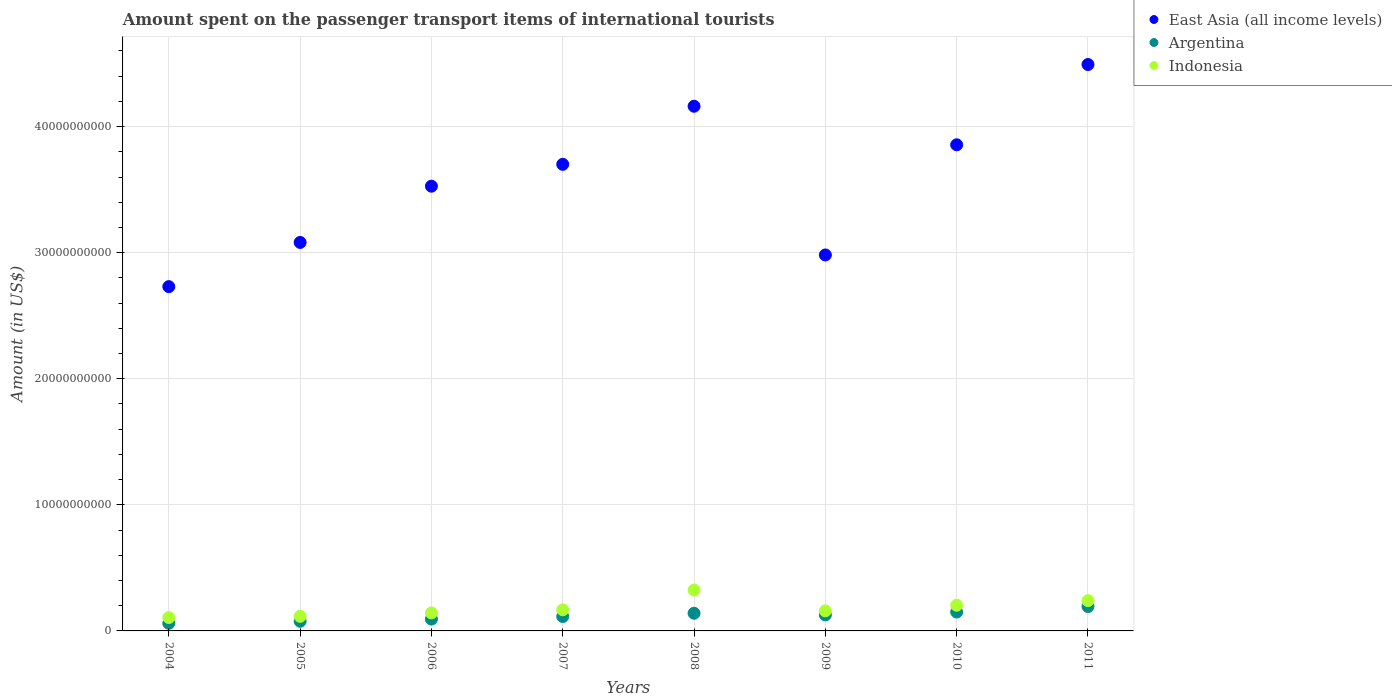How many different coloured dotlines are there?
Ensure brevity in your answer.  3. Is the number of dotlines equal to the number of legend labels?
Offer a terse response. Yes. What is the amount spent on the passenger transport items of international tourists in East Asia (all income levels) in 2004?
Ensure brevity in your answer.  2.73e+1. Across all years, what is the maximum amount spent on the passenger transport items of international tourists in Argentina?
Give a very brief answer. 1.94e+09. Across all years, what is the minimum amount spent on the passenger transport items of international tourists in Argentina?
Keep it short and to the point. 6.04e+08. In which year was the amount spent on the passenger transport items of international tourists in East Asia (all income levels) maximum?
Provide a succinct answer. 2011. In which year was the amount spent on the passenger transport items of international tourists in Argentina minimum?
Your answer should be compact. 2004. What is the total amount spent on the passenger transport items of international tourists in Argentina in the graph?
Offer a terse response. 9.55e+09. What is the difference between the amount spent on the passenger transport items of international tourists in Argentina in 2005 and that in 2011?
Offer a very short reply. -1.17e+09. What is the difference between the amount spent on the passenger transport items of international tourists in Indonesia in 2004 and the amount spent on the passenger transport items of international tourists in Argentina in 2009?
Offer a very short reply. -2.10e+08. What is the average amount spent on the passenger transport items of international tourists in Indonesia per year?
Keep it short and to the point. 1.82e+09. In the year 2006, what is the difference between the amount spent on the passenger transport items of international tourists in East Asia (all income levels) and amount spent on the passenger transport items of international tourists in Indonesia?
Ensure brevity in your answer.  3.38e+1. In how many years, is the amount spent on the passenger transport items of international tourists in East Asia (all income levels) greater than 26000000000 US$?
Offer a terse response. 8. What is the ratio of the amount spent on the passenger transport items of international tourists in Indonesia in 2004 to that in 2011?
Provide a short and direct response. 0.44. Is the difference between the amount spent on the passenger transport items of international tourists in East Asia (all income levels) in 2006 and 2007 greater than the difference between the amount spent on the passenger transport items of international tourists in Indonesia in 2006 and 2007?
Offer a terse response. No. What is the difference between the highest and the second highest amount spent on the passenger transport items of international tourists in Argentina?
Keep it short and to the point. 4.38e+08. What is the difference between the highest and the lowest amount spent on the passenger transport items of international tourists in Indonesia?
Offer a very short reply. 2.18e+09. Does the amount spent on the passenger transport items of international tourists in Indonesia monotonically increase over the years?
Give a very brief answer. No. Does the graph contain any zero values?
Provide a succinct answer. No. How are the legend labels stacked?
Your answer should be compact. Vertical. What is the title of the graph?
Your answer should be very brief. Amount spent on the passenger transport items of international tourists. Does "United Kingdom" appear as one of the legend labels in the graph?
Ensure brevity in your answer.  No. What is the label or title of the X-axis?
Provide a short and direct response. Years. What is the label or title of the Y-axis?
Provide a succinct answer. Amount (in US$). What is the Amount (in US$) in East Asia (all income levels) in 2004?
Your response must be concise. 2.73e+1. What is the Amount (in US$) in Argentina in 2004?
Give a very brief answer. 6.04e+08. What is the Amount (in US$) of Indonesia in 2004?
Your response must be concise. 1.06e+09. What is the Amount (in US$) of East Asia (all income levels) in 2005?
Your answer should be very brief. 3.08e+1. What is the Amount (in US$) of Argentina in 2005?
Offer a terse response. 7.64e+08. What is the Amount (in US$) of Indonesia in 2005?
Make the answer very short. 1.16e+09. What is the Amount (in US$) of East Asia (all income levels) in 2006?
Make the answer very short. 3.53e+1. What is the Amount (in US$) of Argentina in 2006?
Give a very brief answer. 9.39e+08. What is the Amount (in US$) of Indonesia in 2006?
Ensure brevity in your answer.  1.43e+09. What is the Amount (in US$) in East Asia (all income levels) in 2007?
Offer a very short reply. 3.70e+1. What is the Amount (in US$) in Argentina in 2007?
Provide a succinct answer. 1.14e+09. What is the Amount (in US$) of Indonesia in 2007?
Provide a succinct answer. 1.67e+09. What is the Amount (in US$) in East Asia (all income levels) in 2008?
Offer a terse response. 4.16e+1. What is the Amount (in US$) of Argentina in 2008?
Give a very brief answer. 1.40e+09. What is the Amount (in US$) of Indonesia in 2008?
Provide a succinct answer. 3.25e+09. What is the Amount (in US$) in East Asia (all income levels) in 2009?
Offer a terse response. 2.98e+1. What is the Amount (in US$) of Argentina in 2009?
Keep it short and to the point. 1.27e+09. What is the Amount (in US$) in Indonesia in 2009?
Provide a succinct answer. 1.59e+09. What is the Amount (in US$) in East Asia (all income levels) in 2010?
Offer a very short reply. 3.86e+1. What is the Amount (in US$) in Argentina in 2010?
Provide a short and direct response. 1.50e+09. What is the Amount (in US$) of Indonesia in 2010?
Your answer should be compact. 2.04e+09. What is the Amount (in US$) of East Asia (all income levels) in 2011?
Your answer should be very brief. 4.49e+1. What is the Amount (in US$) in Argentina in 2011?
Your response must be concise. 1.94e+09. What is the Amount (in US$) in Indonesia in 2011?
Your response must be concise. 2.40e+09. Across all years, what is the maximum Amount (in US$) in East Asia (all income levels)?
Your response must be concise. 4.49e+1. Across all years, what is the maximum Amount (in US$) in Argentina?
Ensure brevity in your answer.  1.94e+09. Across all years, what is the maximum Amount (in US$) of Indonesia?
Offer a terse response. 3.25e+09. Across all years, what is the minimum Amount (in US$) in East Asia (all income levels)?
Your answer should be compact. 2.73e+1. Across all years, what is the minimum Amount (in US$) in Argentina?
Provide a succinct answer. 6.04e+08. Across all years, what is the minimum Amount (in US$) in Indonesia?
Your answer should be compact. 1.06e+09. What is the total Amount (in US$) in East Asia (all income levels) in the graph?
Ensure brevity in your answer.  2.85e+11. What is the total Amount (in US$) of Argentina in the graph?
Keep it short and to the point. 9.55e+09. What is the total Amount (in US$) of Indonesia in the graph?
Your response must be concise. 1.46e+1. What is the difference between the Amount (in US$) of East Asia (all income levels) in 2004 and that in 2005?
Your answer should be compact. -3.51e+09. What is the difference between the Amount (in US$) of Argentina in 2004 and that in 2005?
Your response must be concise. -1.60e+08. What is the difference between the Amount (in US$) in Indonesia in 2004 and that in 2005?
Provide a succinct answer. -9.40e+07. What is the difference between the Amount (in US$) of East Asia (all income levels) in 2004 and that in 2006?
Your answer should be compact. -7.97e+09. What is the difference between the Amount (in US$) of Argentina in 2004 and that in 2006?
Make the answer very short. -3.35e+08. What is the difference between the Amount (in US$) in Indonesia in 2004 and that in 2006?
Your answer should be compact. -3.66e+08. What is the difference between the Amount (in US$) of East Asia (all income levels) in 2004 and that in 2007?
Ensure brevity in your answer.  -9.70e+09. What is the difference between the Amount (in US$) of Argentina in 2004 and that in 2007?
Your response must be concise. -5.38e+08. What is the difference between the Amount (in US$) of Indonesia in 2004 and that in 2007?
Ensure brevity in your answer.  -6.12e+08. What is the difference between the Amount (in US$) of East Asia (all income levels) in 2004 and that in 2008?
Provide a succinct answer. -1.43e+1. What is the difference between the Amount (in US$) in Argentina in 2004 and that in 2008?
Offer a very short reply. -7.97e+08. What is the difference between the Amount (in US$) in Indonesia in 2004 and that in 2008?
Make the answer very short. -2.18e+09. What is the difference between the Amount (in US$) of East Asia (all income levels) in 2004 and that in 2009?
Offer a terse response. -2.51e+09. What is the difference between the Amount (in US$) of Argentina in 2004 and that in 2009?
Your answer should be very brief. -6.68e+08. What is the difference between the Amount (in US$) in Indonesia in 2004 and that in 2009?
Offer a terse response. -5.30e+08. What is the difference between the Amount (in US$) in East Asia (all income levels) in 2004 and that in 2010?
Provide a succinct answer. -1.12e+1. What is the difference between the Amount (in US$) in Argentina in 2004 and that in 2010?
Provide a short and direct response. -8.93e+08. What is the difference between the Amount (in US$) in Indonesia in 2004 and that in 2010?
Your answer should be very brief. -9.75e+08. What is the difference between the Amount (in US$) in East Asia (all income levels) in 2004 and that in 2011?
Offer a terse response. -1.76e+1. What is the difference between the Amount (in US$) in Argentina in 2004 and that in 2011?
Ensure brevity in your answer.  -1.33e+09. What is the difference between the Amount (in US$) of Indonesia in 2004 and that in 2011?
Your answer should be very brief. -1.34e+09. What is the difference between the Amount (in US$) in East Asia (all income levels) in 2005 and that in 2006?
Keep it short and to the point. -4.46e+09. What is the difference between the Amount (in US$) of Argentina in 2005 and that in 2006?
Ensure brevity in your answer.  -1.75e+08. What is the difference between the Amount (in US$) in Indonesia in 2005 and that in 2006?
Keep it short and to the point. -2.72e+08. What is the difference between the Amount (in US$) of East Asia (all income levels) in 2005 and that in 2007?
Your answer should be very brief. -6.20e+09. What is the difference between the Amount (in US$) in Argentina in 2005 and that in 2007?
Offer a terse response. -3.78e+08. What is the difference between the Amount (in US$) of Indonesia in 2005 and that in 2007?
Give a very brief answer. -5.18e+08. What is the difference between the Amount (in US$) in East Asia (all income levels) in 2005 and that in 2008?
Provide a succinct answer. -1.08e+1. What is the difference between the Amount (in US$) of Argentina in 2005 and that in 2008?
Ensure brevity in your answer.  -6.37e+08. What is the difference between the Amount (in US$) in Indonesia in 2005 and that in 2008?
Your answer should be compact. -2.09e+09. What is the difference between the Amount (in US$) in East Asia (all income levels) in 2005 and that in 2009?
Your answer should be very brief. 9.93e+08. What is the difference between the Amount (in US$) of Argentina in 2005 and that in 2009?
Your response must be concise. -5.08e+08. What is the difference between the Amount (in US$) in Indonesia in 2005 and that in 2009?
Provide a short and direct response. -4.36e+08. What is the difference between the Amount (in US$) in East Asia (all income levels) in 2005 and that in 2010?
Your answer should be compact. -7.74e+09. What is the difference between the Amount (in US$) of Argentina in 2005 and that in 2010?
Ensure brevity in your answer.  -7.33e+08. What is the difference between the Amount (in US$) in Indonesia in 2005 and that in 2010?
Provide a short and direct response. -8.81e+08. What is the difference between the Amount (in US$) in East Asia (all income levels) in 2005 and that in 2011?
Provide a succinct answer. -1.41e+1. What is the difference between the Amount (in US$) in Argentina in 2005 and that in 2011?
Offer a terse response. -1.17e+09. What is the difference between the Amount (in US$) in Indonesia in 2005 and that in 2011?
Your answer should be very brief. -1.24e+09. What is the difference between the Amount (in US$) in East Asia (all income levels) in 2006 and that in 2007?
Give a very brief answer. -1.73e+09. What is the difference between the Amount (in US$) of Argentina in 2006 and that in 2007?
Offer a terse response. -2.03e+08. What is the difference between the Amount (in US$) of Indonesia in 2006 and that in 2007?
Offer a terse response. -2.46e+08. What is the difference between the Amount (in US$) in East Asia (all income levels) in 2006 and that in 2008?
Give a very brief answer. -6.34e+09. What is the difference between the Amount (in US$) of Argentina in 2006 and that in 2008?
Ensure brevity in your answer.  -4.62e+08. What is the difference between the Amount (in US$) in Indonesia in 2006 and that in 2008?
Provide a succinct answer. -1.82e+09. What is the difference between the Amount (in US$) of East Asia (all income levels) in 2006 and that in 2009?
Your answer should be compact. 5.45e+09. What is the difference between the Amount (in US$) in Argentina in 2006 and that in 2009?
Make the answer very short. -3.33e+08. What is the difference between the Amount (in US$) of Indonesia in 2006 and that in 2009?
Your answer should be very brief. -1.64e+08. What is the difference between the Amount (in US$) in East Asia (all income levels) in 2006 and that in 2010?
Your response must be concise. -3.28e+09. What is the difference between the Amount (in US$) in Argentina in 2006 and that in 2010?
Ensure brevity in your answer.  -5.58e+08. What is the difference between the Amount (in US$) of Indonesia in 2006 and that in 2010?
Your answer should be very brief. -6.09e+08. What is the difference between the Amount (in US$) of East Asia (all income levels) in 2006 and that in 2011?
Provide a succinct answer. -9.65e+09. What is the difference between the Amount (in US$) of Argentina in 2006 and that in 2011?
Give a very brief answer. -9.96e+08. What is the difference between the Amount (in US$) of Indonesia in 2006 and that in 2011?
Offer a very short reply. -9.70e+08. What is the difference between the Amount (in US$) of East Asia (all income levels) in 2007 and that in 2008?
Make the answer very short. -4.61e+09. What is the difference between the Amount (in US$) in Argentina in 2007 and that in 2008?
Your answer should be very brief. -2.59e+08. What is the difference between the Amount (in US$) in Indonesia in 2007 and that in 2008?
Your answer should be very brief. -1.57e+09. What is the difference between the Amount (in US$) in East Asia (all income levels) in 2007 and that in 2009?
Provide a succinct answer. 7.19e+09. What is the difference between the Amount (in US$) in Argentina in 2007 and that in 2009?
Provide a succinct answer. -1.30e+08. What is the difference between the Amount (in US$) of Indonesia in 2007 and that in 2009?
Make the answer very short. 8.20e+07. What is the difference between the Amount (in US$) in East Asia (all income levels) in 2007 and that in 2010?
Offer a very short reply. -1.55e+09. What is the difference between the Amount (in US$) of Argentina in 2007 and that in 2010?
Make the answer very short. -3.55e+08. What is the difference between the Amount (in US$) of Indonesia in 2007 and that in 2010?
Provide a succinct answer. -3.63e+08. What is the difference between the Amount (in US$) in East Asia (all income levels) in 2007 and that in 2011?
Offer a very short reply. -7.92e+09. What is the difference between the Amount (in US$) in Argentina in 2007 and that in 2011?
Provide a short and direct response. -7.93e+08. What is the difference between the Amount (in US$) in Indonesia in 2007 and that in 2011?
Keep it short and to the point. -7.24e+08. What is the difference between the Amount (in US$) of East Asia (all income levels) in 2008 and that in 2009?
Offer a very short reply. 1.18e+1. What is the difference between the Amount (in US$) in Argentina in 2008 and that in 2009?
Give a very brief answer. 1.29e+08. What is the difference between the Amount (in US$) in Indonesia in 2008 and that in 2009?
Your response must be concise. 1.66e+09. What is the difference between the Amount (in US$) in East Asia (all income levels) in 2008 and that in 2010?
Offer a terse response. 3.06e+09. What is the difference between the Amount (in US$) in Argentina in 2008 and that in 2010?
Offer a terse response. -9.60e+07. What is the difference between the Amount (in US$) in Indonesia in 2008 and that in 2010?
Your response must be concise. 1.21e+09. What is the difference between the Amount (in US$) of East Asia (all income levels) in 2008 and that in 2011?
Provide a succinct answer. -3.31e+09. What is the difference between the Amount (in US$) in Argentina in 2008 and that in 2011?
Ensure brevity in your answer.  -5.34e+08. What is the difference between the Amount (in US$) of Indonesia in 2008 and that in 2011?
Provide a succinct answer. 8.49e+08. What is the difference between the Amount (in US$) in East Asia (all income levels) in 2009 and that in 2010?
Provide a short and direct response. -8.74e+09. What is the difference between the Amount (in US$) of Argentina in 2009 and that in 2010?
Provide a succinct answer. -2.25e+08. What is the difference between the Amount (in US$) in Indonesia in 2009 and that in 2010?
Provide a short and direct response. -4.45e+08. What is the difference between the Amount (in US$) of East Asia (all income levels) in 2009 and that in 2011?
Give a very brief answer. -1.51e+1. What is the difference between the Amount (in US$) in Argentina in 2009 and that in 2011?
Make the answer very short. -6.63e+08. What is the difference between the Amount (in US$) in Indonesia in 2009 and that in 2011?
Make the answer very short. -8.06e+08. What is the difference between the Amount (in US$) in East Asia (all income levels) in 2010 and that in 2011?
Give a very brief answer. -6.37e+09. What is the difference between the Amount (in US$) in Argentina in 2010 and that in 2011?
Offer a terse response. -4.38e+08. What is the difference between the Amount (in US$) of Indonesia in 2010 and that in 2011?
Provide a succinct answer. -3.61e+08. What is the difference between the Amount (in US$) of East Asia (all income levels) in 2004 and the Amount (in US$) of Argentina in 2005?
Keep it short and to the point. 2.65e+1. What is the difference between the Amount (in US$) of East Asia (all income levels) in 2004 and the Amount (in US$) of Indonesia in 2005?
Offer a terse response. 2.61e+1. What is the difference between the Amount (in US$) of Argentina in 2004 and the Amount (in US$) of Indonesia in 2005?
Keep it short and to the point. -5.52e+08. What is the difference between the Amount (in US$) in East Asia (all income levels) in 2004 and the Amount (in US$) in Argentina in 2006?
Keep it short and to the point. 2.64e+1. What is the difference between the Amount (in US$) in East Asia (all income levels) in 2004 and the Amount (in US$) in Indonesia in 2006?
Give a very brief answer. 2.59e+1. What is the difference between the Amount (in US$) of Argentina in 2004 and the Amount (in US$) of Indonesia in 2006?
Provide a succinct answer. -8.24e+08. What is the difference between the Amount (in US$) in East Asia (all income levels) in 2004 and the Amount (in US$) in Argentina in 2007?
Your response must be concise. 2.62e+1. What is the difference between the Amount (in US$) of East Asia (all income levels) in 2004 and the Amount (in US$) of Indonesia in 2007?
Offer a very short reply. 2.56e+1. What is the difference between the Amount (in US$) of Argentina in 2004 and the Amount (in US$) of Indonesia in 2007?
Provide a succinct answer. -1.07e+09. What is the difference between the Amount (in US$) in East Asia (all income levels) in 2004 and the Amount (in US$) in Argentina in 2008?
Offer a very short reply. 2.59e+1. What is the difference between the Amount (in US$) of East Asia (all income levels) in 2004 and the Amount (in US$) of Indonesia in 2008?
Ensure brevity in your answer.  2.41e+1. What is the difference between the Amount (in US$) in Argentina in 2004 and the Amount (in US$) in Indonesia in 2008?
Provide a short and direct response. -2.64e+09. What is the difference between the Amount (in US$) in East Asia (all income levels) in 2004 and the Amount (in US$) in Argentina in 2009?
Give a very brief answer. 2.60e+1. What is the difference between the Amount (in US$) in East Asia (all income levels) in 2004 and the Amount (in US$) in Indonesia in 2009?
Make the answer very short. 2.57e+1. What is the difference between the Amount (in US$) of Argentina in 2004 and the Amount (in US$) of Indonesia in 2009?
Your answer should be compact. -9.88e+08. What is the difference between the Amount (in US$) of East Asia (all income levels) in 2004 and the Amount (in US$) of Argentina in 2010?
Give a very brief answer. 2.58e+1. What is the difference between the Amount (in US$) in East Asia (all income levels) in 2004 and the Amount (in US$) in Indonesia in 2010?
Give a very brief answer. 2.53e+1. What is the difference between the Amount (in US$) of Argentina in 2004 and the Amount (in US$) of Indonesia in 2010?
Offer a very short reply. -1.43e+09. What is the difference between the Amount (in US$) in East Asia (all income levels) in 2004 and the Amount (in US$) in Argentina in 2011?
Your answer should be compact. 2.54e+1. What is the difference between the Amount (in US$) of East Asia (all income levels) in 2004 and the Amount (in US$) of Indonesia in 2011?
Offer a very short reply. 2.49e+1. What is the difference between the Amount (in US$) in Argentina in 2004 and the Amount (in US$) in Indonesia in 2011?
Provide a short and direct response. -1.79e+09. What is the difference between the Amount (in US$) of East Asia (all income levels) in 2005 and the Amount (in US$) of Argentina in 2006?
Your answer should be very brief. 2.99e+1. What is the difference between the Amount (in US$) of East Asia (all income levels) in 2005 and the Amount (in US$) of Indonesia in 2006?
Ensure brevity in your answer.  2.94e+1. What is the difference between the Amount (in US$) in Argentina in 2005 and the Amount (in US$) in Indonesia in 2006?
Offer a very short reply. -6.64e+08. What is the difference between the Amount (in US$) in East Asia (all income levels) in 2005 and the Amount (in US$) in Argentina in 2007?
Provide a short and direct response. 2.97e+1. What is the difference between the Amount (in US$) of East Asia (all income levels) in 2005 and the Amount (in US$) of Indonesia in 2007?
Provide a short and direct response. 2.91e+1. What is the difference between the Amount (in US$) of Argentina in 2005 and the Amount (in US$) of Indonesia in 2007?
Provide a succinct answer. -9.10e+08. What is the difference between the Amount (in US$) in East Asia (all income levels) in 2005 and the Amount (in US$) in Argentina in 2008?
Offer a very short reply. 2.94e+1. What is the difference between the Amount (in US$) in East Asia (all income levels) in 2005 and the Amount (in US$) in Indonesia in 2008?
Provide a succinct answer. 2.76e+1. What is the difference between the Amount (in US$) of Argentina in 2005 and the Amount (in US$) of Indonesia in 2008?
Your response must be concise. -2.48e+09. What is the difference between the Amount (in US$) of East Asia (all income levels) in 2005 and the Amount (in US$) of Argentina in 2009?
Offer a terse response. 2.95e+1. What is the difference between the Amount (in US$) of East Asia (all income levels) in 2005 and the Amount (in US$) of Indonesia in 2009?
Your answer should be very brief. 2.92e+1. What is the difference between the Amount (in US$) of Argentina in 2005 and the Amount (in US$) of Indonesia in 2009?
Your answer should be very brief. -8.28e+08. What is the difference between the Amount (in US$) of East Asia (all income levels) in 2005 and the Amount (in US$) of Argentina in 2010?
Ensure brevity in your answer.  2.93e+1. What is the difference between the Amount (in US$) of East Asia (all income levels) in 2005 and the Amount (in US$) of Indonesia in 2010?
Provide a short and direct response. 2.88e+1. What is the difference between the Amount (in US$) of Argentina in 2005 and the Amount (in US$) of Indonesia in 2010?
Provide a short and direct response. -1.27e+09. What is the difference between the Amount (in US$) of East Asia (all income levels) in 2005 and the Amount (in US$) of Argentina in 2011?
Provide a succinct answer. 2.89e+1. What is the difference between the Amount (in US$) of East Asia (all income levels) in 2005 and the Amount (in US$) of Indonesia in 2011?
Your answer should be compact. 2.84e+1. What is the difference between the Amount (in US$) of Argentina in 2005 and the Amount (in US$) of Indonesia in 2011?
Keep it short and to the point. -1.63e+09. What is the difference between the Amount (in US$) in East Asia (all income levels) in 2006 and the Amount (in US$) in Argentina in 2007?
Offer a very short reply. 3.41e+1. What is the difference between the Amount (in US$) of East Asia (all income levels) in 2006 and the Amount (in US$) of Indonesia in 2007?
Keep it short and to the point. 3.36e+1. What is the difference between the Amount (in US$) of Argentina in 2006 and the Amount (in US$) of Indonesia in 2007?
Your answer should be very brief. -7.35e+08. What is the difference between the Amount (in US$) of East Asia (all income levels) in 2006 and the Amount (in US$) of Argentina in 2008?
Provide a short and direct response. 3.39e+1. What is the difference between the Amount (in US$) of East Asia (all income levels) in 2006 and the Amount (in US$) of Indonesia in 2008?
Keep it short and to the point. 3.20e+1. What is the difference between the Amount (in US$) of Argentina in 2006 and the Amount (in US$) of Indonesia in 2008?
Ensure brevity in your answer.  -2.31e+09. What is the difference between the Amount (in US$) of East Asia (all income levels) in 2006 and the Amount (in US$) of Argentina in 2009?
Ensure brevity in your answer.  3.40e+1. What is the difference between the Amount (in US$) in East Asia (all income levels) in 2006 and the Amount (in US$) in Indonesia in 2009?
Make the answer very short. 3.37e+1. What is the difference between the Amount (in US$) of Argentina in 2006 and the Amount (in US$) of Indonesia in 2009?
Make the answer very short. -6.53e+08. What is the difference between the Amount (in US$) of East Asia (all income levels) in 2006 and the Amount (in US$) of Argentina in 2010?
Your answer should be very brief. 3.38e+1. What is the difference between the Amount (in US$) of East Asia (all income levels) in 2006 and the Amount (in US$) of Indonesia in 2010?
Give a very brief answer. 3.32e+1. What is the difference between the Amount (in US$) in Argentina in 2006 and the Amount (in US$) in Indonesia in 2010?
Give a very brief answer. -1.10e+09. What is the difference between the Amount (in US$) of East Asia (all income levels) in 2006 and the Amount (in US$) of Argentina in 2011?
Your response must be concise. 3.33e+1. What is the difference between the Amount (in US$) of East Asia (all income levels) in 2006 and the Amount (in US$) of Indonesia in 2011?
Offer a very short reply. 3.29e+1. What is the difference between the Amount (in US$) of Argentina in 2006 and the Amount (in US$) of Indonesia in 2011?
Offer a very short reply. -1.46e+09. What is the difference between the Amount (in US$) of East Asia (all income levels) in 2007 and the Amount (in US$) of Argentina in 2008?
Provide a short and direct response. 3.56e+1. What is the difference between the Amount (in US$) in East Asia (all income levels) in 2007 and the Amount (in US$) in Indonesia in 2008?
Make the answer very short. 3.38e+1. What is the difference between the Amount (in US$) in Argentina in 2007 and the Amount (in US$) in Indonesia in 2008?
Provide a succinct answer. -2.10e+09. What is the difference between the Amount (in US$) of East Asia (all income levels) in 2007 and the Amount (in US$) of Argentina in 2009?
Give a very brief answer. 3.57e+1. What is the difference between the Amount (in US$) in East Asia (all income levels) in 2007 and the Amount (in US$) in Indonesia in 2009?
Your answer should be very brief. 3.54e+1. What is the difference between the Amount (in US$) of Argentina in 2007 and the Amount (in US$) of Indonesia in 2009?
Make the answer very short. -4.50e+08. What is the difference between the Amount (in US$) in East Asia (all income levels) in 2007 and the Amount (in US$) in Argentina in 2010?
Your answer should be very brief. 3.55e+1. What is the difference between the Amount (in US$) in East Asia (all income levels) in 2007 and the Amount (in US$) in Indonesia in 2010?
Provide a succinct answer. 3.50e+1. What is the difference between the Amount (in US$) in Argentina in 2007 and the Amount (in US$) in Indonesia in 2010?
Keep it short and to the point. -8.95e+08. What is the difference between the Amount (in US$) of East Asia (all income levels) in 2007 and the Amount (in US$) of Argentina in 2011?
Ensure brevity in your answer.  3.51e+1. What is the difference between the Amount (in US$) of East Asia (all income levels) in 2007 and the Amount (in US$) of Indonesia in 2011?
Give a very brief answer. 3.46e+1. What is the difference between the Amount (in US$) of Argentina in 2007 and the Amount (in US$) of Indonesia in 2011?
Provide a succinct answer. -1.26e+09. What is the difference between the Amount (in US$) in East Asia (all income levels) in 2008 and the Amount (in US$) in Argentina in 2009?
Offer a very short reply. 4.03e+1. What is the difference between the Amount (in US$) in East Asia (all income levels) in 2008 and the Amount (in US$) in Indonesia in 2009?
Offer a very short reply. 4.00e+1. What is the difference between the Amount (in US$) of Argentina in 2008 and the Amount (in US$) of Indonesia in 2009?
Your answer should be very brief. -1.91e+08. What is the difference between the Amount (in US$) in East Asia (all income levels) in 2008 and the Amount (in US$) in Argentina in 2010?
Your answer should be compact. 4.01e+1. What is the difference between the Amount (in US$) of East Asia (all income levels) in 2008 and the Amount (in US$) of Indonesia in 2010?
Your response must be concise. 3.96e+1. What is the difference between the Amount (in US$) of Argentina in 2008 and the Amount (in US$) of Indonesia in 2010?
Offer a very short reply. -6.36e+08. What is the difference between the Amount (in US$) of East Asia (all income levels) in 2008 and the Amount (in US$) of Argentina in 2011?
Offer a very short reply. 3.97e+1. What is the difference between the Amount (in US$) of East Asia (all income levels) in 2008 and the Amount (in US$) of Indonesia in 2011?
Keep it short and to the point. 3.92e+1. What is the difference between the Amount (in US$) in Argentina in 2008 and the Amount (in US$) in Indonesia in 2011?
Your response must be concise. -9.97e+08. What is the difference between the Amount (in US$) of East Asia (all income levels) in 2009 and the Amount (in US$) of Argentina in 2010?
Your response must be concise. 2.83e+1. What is the difference between the Amount (in US$) in East Asia (all income levels) in 2009 and the Amount (in US$) in Indonesia in 2010?
Offer a terse response. 2.78e+1. What is the difference between the Amount (in US$) in Argentina in 2009 and the Amount (in US$) in Indonesia in 2010?
Make the answer very short. -7.65e+08. What is the difference between the Amount (in US$) of East Asia (all income levels) in 2009 and the Amount (in US$) of Argentina in 2011?
Give a very brief answer. 2.79e+1. What is the difference between the Amount (in US$) in East Asia (all income levels) in 2009 and the Amount (in US$) in Indonesia in 2011?
Offer a very short reply. 2.74e+1. What is the difference between the Amount (in US$) of Argentina in 2009 and the Amount (in US$) of Indonesia in 2011?
Keep it short and to the point. -1.13e+09. What is the difference between the Amount (in US$) of East Asia (all income levels) in 2010 and the Amount (in US$) of Argentina in 2011?
Provide a short and direct response. 3.66e+1. What is the difference between the Amount (in US$) in East Asia (all income levels) in 2010 and the Amount (in US$) in Indonesia in 2011?
Provide a short and direct response. 3.62e+1. What is the difference between the Amount (in US$) of Argentina in 2010 and the Amount (in US$) of Indonesia in 2011?
Provide a short and direct response. -9.01e+08. What is the average Amount (in US$) in East Asia (all income levels) per year?
Provide a short and direct response. 3.57e+1. What is the average Amount (in US$) in Argentina per year?
Keep it short and to the point. 1.19e+09. What is the average Amount (in US$) of Indonesia per year?
Provide a short and direct response. 1.82e+09. In the year 2004, what is the difference between the Amount (in US$) of East Asia (all income levels) and Amount (in US$) of Argentina?
Ensure brevity in your answer.  2.67e+1. In the year 2004, what is the difference between the Amount (in US$) in East Asia (all income levels) and Amount (in US$) in Indonesia?
Make the answer very short. 2.62e+1. In the year 2004, what is the difference between the Amount (in US$) in Argentina and Amount (in US$) in Indonesia?
Provide a succinct answer. -4.58e+08. In the year 2005, what is the difference between the Amount (in US$) in East Asia (all income levels) and Amount (in US$) in Argentina?
Keep it short and to the point. 3.00e+1. In the year 2005, what is the difference between the Amount (in US$) in East Asia (all income levels) and Amount (in US$) in Indonesia?
Provide a short and direct response. 2.97e+1. In the year 2005, what is the difference between the Amount (in US$) in Argentina and Amount (in US$) in Indonesia?
Your answer should be compact. -3.92e+08. In the year 2006, what is the difference between the Amount (in US$) of East Asia (all income levels) and Amount (in US$) of Argentina?
Your answer should be very brief. 3.43e+1. In the year 2006, what is the difference between the Amount (in US$) of East Asia (all income levels) and Amount (in US$) of Indonesia?
Provide a succinct answer. 3.38e+1. In the year 2006, what is the difference between the Amount (in US$) of Argentina and Amount (in US$) of Indonesia?
Provide a succinct answer. -4.89e+08. In the year 2007, what is the difference between the Amount (in US$) in East Asia (all income levels) and Amount (in US$) in Argentina?
Your answer should be compact. 3.59e+1. In the year 2007, what is the difference between the Amount (in US$) of East Asia (all income levels) and Amount (in US$) of Indonesia?
Make the answer very short. 3.53e+1. In the year 2007, what is the difference between the Amount (in US$) in Argentina and Amount (in US$) in Indonesia?
Give a very brief answer. -5.32e+08. In the year 2008, what is the difference between the Amount (in US$) of East Asia (all income levels) and Amount (in US$) of Argentina?
Make the answer very short. 4.02e+1. In the year 2008, what is the difference between the Amount (in US$) of East Asia (all income levels) and Amount (in US$) of Indonesia?
Make the answer very short. 3.84e+1. In the year 2008, what is the difference between the Amount (in US$) in Argentina and Amount (in US$) in Indonesia?
Your answer should be very brief. -1.85e+09. In the year 2009, what is the difference between the Amount (in US$) in East Asia (all income levels) and Amount (in US$) in Argentina?
Offer a terse response. 2.85e+1. In the year 2009, what is the difference between the Amount (in US$) in East Asia (all income levels) and Amount (in US$) in Indonesia?
Provide a short and direct response. 2.82e+1. In the year 2009, what is the difference between the Amount (in US$) of Argentina and Amount (in US$) of Indonesia?
Provide a succinct answer. -3.20e+08. In the year 2010, what is the difference between the Amount (in US$) in East Asia (all income levels) and Amount (in US$) in Argentina?
Provide a succinct answer. 3.71e+1. In the year 2010, what is the difference between the Amount (in US$) of East Asia (all income levels) and Amount (in US$) of Indonesia?
Your answer should be very brief. 3.65e+1. In the year 2010, what is the difference between the Amount (in US$) of Argentina and Amount (in US$) of Indonesia?
Your answer should be compact. -5.40e+08. In the year 2011, what is the difference between the Amount (in US$) of East Asia (all income levels) and Amount (in US$) of Argentina?
Your answer should be very brief. 4.30e+1. In the year 2011, what is the difference between the Amount (in US$) in East Asia (all income levels) and Amount (in US$) in Indonesia?
Keep it short and to the point. 4.25e+1. In the year 2011, what is the difference between the Amount (in US$) of Argentina and Amount (in US$) of Indonesia?
Provide a short and direct response. -4.63e+08. What is the ratio of the Amount (in US$) of East Asia (all income levels) in 2004 to that in 2005?
Offer a very short reply. 0.89. What is the ratio of the Amount (in US$) in Argentina in 2004 to that in 2005?
Offer a very short reply. 0.79. What is the ratio of the Amount (in US$) of Indonesia in 2004 to that in 2005?
Keep it short and to the point. 0.92. What is the ratio of the Amount (in US$) of East Asia (all income levels) in 2004 to that in 2006?
Provide a succinct answer. 0.77. What is the ratio of the Amount (in US$) of Argentina in 2004 to that in 2006?
Your answer should be compact. 0.64. What is the ratio of the Amount (in US$) in Indonesia in 2004 to that in 2006?
Provide a succinct answer. 0.74. What is the ratio of the Amount (in US$) of East Asia (all income levels) in 2004 to that in 2007?
Provide a short and direct response. 0.74. What is the ratio of the Amount (in US$) in Argentina in 2004 to that in 2007?
Offer a very short reply. 0.53. What is the ratio of the Amount (in US$) in Indonesia in 2004 to that in 2007?
Ensure brevity in your answer.  0.63. What is the ratio of the Amount (in US$) of East Asia (all income levels) in 2004 to that in 2008?
Offer a terse response. 0.66. What is the ratio of the Amount (in US$) in Argentina in 2004 to that in 2008?
Your answer should be very brief. 0.43. What is the ratio of the Amount (in US$) of Indonesia in 2004 to that in 2008?
Offer a terse response. 0.33. What is the ratio of the Amount (in US$) in East Asia (all income levels) in 2004 to that in 2009?
Offer a terse response. 0.92. What is the ratio of the Amount (in US$) in Argentina in 2004 to that in 2009?
Offer a terse response. 0.47. What is the ratio of the Amount (in US$) in Indonesia in 2004 to that in 2009?
Your answer should be very brief. 0.67. What is the ratio of the Amount (in US$) in East Asia (all income levels) in 2004 to that in 2010?
Offer a terse response. 0.71. What is the ratio of the Amount (in US$) in Argentina in 2004 to that in 2010?
Offer a terse response. 0.4. What is the ratio of the Amount (in US$) of Indonesia in 2004 to that in 2010?
Your response must be concise. 0.52. What is the ratio of the Amount (in US$) of East Asia (all income levels) in 2004 to that in 2011?
Your answer should be compact. 0.61. What is the ratio of the Amount (in US$) of Argentina in 2004 to that in 2011?
Your answer should be compact. 0.31. What is the ratio of the Amount (in US$) of Indonesia in 2004 to that in 2011?
Offer a very short reply. 0.44. What is the ratio of the Amount (in US$) in East Asia (all income levels) in 2005 to that in 2006?
Ensure brevity in your answer.  0.87. What is the ratio of the Amount (in US$) in Argentina in 2005 to that in 2006?
Offer a very short reply. 0.81. What is the ratio of the Amount (in US$) of Indonesia in 2005 to that in 2006?
Keep it short and to the point. 0.81. What is the ratio of the Amount (in US$) of East Asia (all income levels) in 2005 to that in 2007?
Provide a succinct answer. 0.83. What is the ratio of the Amount (in US$) of Argentina in 2005 to that in 2007?
Provide a succinct answer. 0.67. What is the ratio of the Amount (in US$) in Indonesia in 2005 to that in 2007?
Your response must be concise. 0.69. What is the ratio of the Amount (in US$) of East Asia (all income levels) in 2005 to that in 2008?
Your response must be concise. 0.74. What is the ratio of the Amount (in US$) in Argentina in 2005 to that in 2008?
Provide a short and direct response. 0.55. What is the ratio of the Amount (in US$) of Indonesia in 2005 to that in 2008?
Your answer should be very brief. 0.36. What is the ratio of the Amount (in US$) in Argentina in 2005 to that in 2009?
Ensure brevity in your answer.  0.6. What is the ratio of the Amount (in US$) of Indonesia in 2005 to that in 2009?
Your answer should be very brief. 0.73. What is the ratio of the Amount (in US$) of East Asia (all income levels) in 2005 to that in 2010?
Offer a very short reply. 0.8. What is the ratio of the Amount (in US$) in Argentina in 2005 to that in 2010?
Your answer should be compact. 0.51. What is the ratio of the Amount (in US$) of Indonesia in 2005 to that in 2010?
Your answer should be very brief. 0.57. What is the ratio of the Amount (in US$) of East Asia (all income levels) in 2005 to that in 2011?
Keep it short and to the point. 0.69. What is the ratio of the Amount (in US$) of Argentina in 2005 to that in 2011?
Make the answer very short. 0.39. What is the ratio of the Amount (in US$) in Indonesia in 2005 to that in 2011?
Offer a terse response. 0.48. What is the ratio of the Amount (in US$) of East Asia (all income levels) in 2006 to that in 2007?
Offer a very short reply. 0.95. What is the ratio of the Amount (in US$) of Argentina in 2006 to that in 2007?
Your response must be concise. 0.82. What is the ratio of the Amount (in US$) of Indonesia in 2006 to that in 2007?
Provide a short and direct response. 0.85. What is the ratio of the Amount (in US$) of East Asia (all income levels) in 2006 to that in 2008?
Provide a short and direct response. 0.85. What is the ratio of the Amount (in US$) of Argentina in 2006 to that in 2008?
Your answer should be compact. 0.67. What is the ratio of the Amount (in US$) in Indonesia in 2006 to that in 2008?
Offer a terse response. 0.44. What is the ratio of the Amount (in US$) in East Asia (all income levels) in 2006 to that in 2009?
Offer a very short reply. 1.18. What is the ratio of the Amount (in US$) in Argentina in 2006 to that in 2009?
Ensure brevity in your answer.  0.74. What is the ratio of the Amount (in US$) in Indonesia in 2006 to that in 2009?
Offer a very short reply. 0.9. What is the ratio of the Amount (in US$) in East Asia (all income levels) in 2006 to that in 2010?
Provide a succinct answer. 0.91. What is the ratio of the Amount (in US$) of Argentina in 2006 to that in 2010?
Give a very brief answer. 0.63. What is the ratio of the Amount (in US$) in Indonesia in 2006 to that in 2010?
Your response must be concise. 0.7. What is the ratio of the Amount (in US$) in East Asia (all income levels) in 2006 to that in 2011?
Make the answer very short. 0.79. What is the ratio of the Amount (in US$) of Argentina in 2006 to that in 2011?
Provide a succinct answer. 0.49. What is the ratio of the Amount (in US$) in Indonesia in 2006 to that in 2011?
Provide a short and direct response. 0.6. What is the ratio of the Amount (in US$) in East Asia (all income levels) in 2007 to that in 2008?
Offer a very short reply. 0.89. What is the ratio of the Amount (in US$) of Argentina in 2007 to that in 2008?
Provide a short and direct response. 0.82. What is the ratio of the Amount (in US$) of Indonesia in 2007 to that in 2008?
Your answer should be very brief. 0.52. What is the ratio of the Amount (in US$) in East Asia (all income levels) in 2007 to that in 2009?
Your response must be concise. 1.24. What is the ratio of the Amount (in US$) in Argentina in 2007 to that in 2009?
Keep it short and to the point. 0.9. What is the ratio of the Amount (in US$) of Indonesia in 2007 to that in 2009?
Provide a short and direct response. 1.05. What is the ratio of the Amount (in US$) of East Asia (all income levels) in 2007 to that in 2010?
Ensure brevity in your answer.  0.96. What is the ratio of the Amount (in US$) in Argentina in 2007 to that in 2010?
Give a very brief answer. 0.76. What is the ratio of the Amount (in US$) in Indonesia in 2007 to that in 2010?
Your response must be concise. 0.82. What is the ratio of the Amount (in US$) of East Asia (all income levels) in 2007 to that in 2011?
Provide a short and direct response. 0.82. What is the ratio of the Amount (in US$) of Argentina in 2007 to that in 2011?
Keep it short and to the point. 0.59. What is the ratio of the Amount (in US$) of Indonesia in 2007 to that in 2011?
Make the answer very short. 0.7. What is the ratio of the Amount (in US$) of East Asia (all income levels) in 2008 to that in 2009?
Your response must be concise. 1.4. What is the ratio of the Amount (in US$) of Argentina in 2008 to that in 2009?
Provide a short and direct response. 1.1. What is the ratio of the Amount (in US$) of Indonesia in 2008 to that in 2009?
Your answer should be very brief. 2.04. What is the ratio of the Amount (in US$) of East Asia (all income levels) in 2008 to that in 2010?
Give a very brief answer. 1.08. What is the ratio of the Amount (in US$) of Argentina in 2008 to that in 2010?
Make the answer very short. 0.94. What is the ratio of the Amount (in US$) in Indonesia in 2008 to that in 2010?
Offer a terse response. 1.59. What is the ratio of the Amount (in US$) of East Asia (all income levels) in 2008 to that in 2011?
Offer a terse response. 0.93. What is the ratio of the Amount (in US$) in Argentina in 2008 to that in 2011?
Keep it short and to the point. 0.72. What is the ratio of the Amount (in US$) of Indonesia in 2008 to that in 2011?
Offer a terse response. 1.35. What is the ratio of the Amount (in US$) in East Asia (all income levels) in 2009 to that in 2010?
Provide a short and direct response. 0.77. What is the ratio of the Amount (in US$) of Argentina in 2009 to that in 2010?
Your answer should be very brief. 0.85. What is the ratio of the Amount (in US$) in Indonesia in 2009 to that in 2010?
Ensure brevity in your answer.  0.78. What is the ratio of the Amount (in US$) in East Asia (all income levels) in 2009 to that in 2011?
Ensure brevity in your answer.  0.66. What is the ratio of the Amount (in US$) in Argentina in 2009 to that in 2011?
Give a very brief answer. 0.66. What is the ratio of the Amount (in US$) in Indonesia in 2009 to that in 2011?
Offer a very short reply. 0.66. What is the ratio of the Amount (in US$) in East Asia (all income levels) in 2010 to that in 2011?
Offer a terse response. 0.86. What is the ratio of the Amount (in US$) of Argentina in 2010 to that in 2011?
Provide a succinct answer. 0.77. What is the ratio of the Amount (in US$) of Indonesia in 2010 to that in 2011?
Give a very brief answer. 0.85. What is the difference between the highest and the second highest Amount (in US$) in East Asia (all income levels)?
Provide a succinct answer. 3.31e+09. What is the difference between the highest and the second highest Amount (in US$) of Argentina?
Provide a succinct answer. 4.38e+08. What is the difference between the highest and the second highest Amount (in US$) of Indonesia?
Keep it short and to the point. 8.49e+08. What is the difference between the highest and the lowest Amount (in US$) in East Asia (all income levels)?
Give a very brief answer. 1.76e+1. What is the difference between the highest and the lowest Amount (in US$) in Argentina?
Make the answer very short. 1.33e+09. What is the difference between the highest and the lowest Amount (in US$) of Indonesia?
Provide a short and direct response. 2.18e+09. 